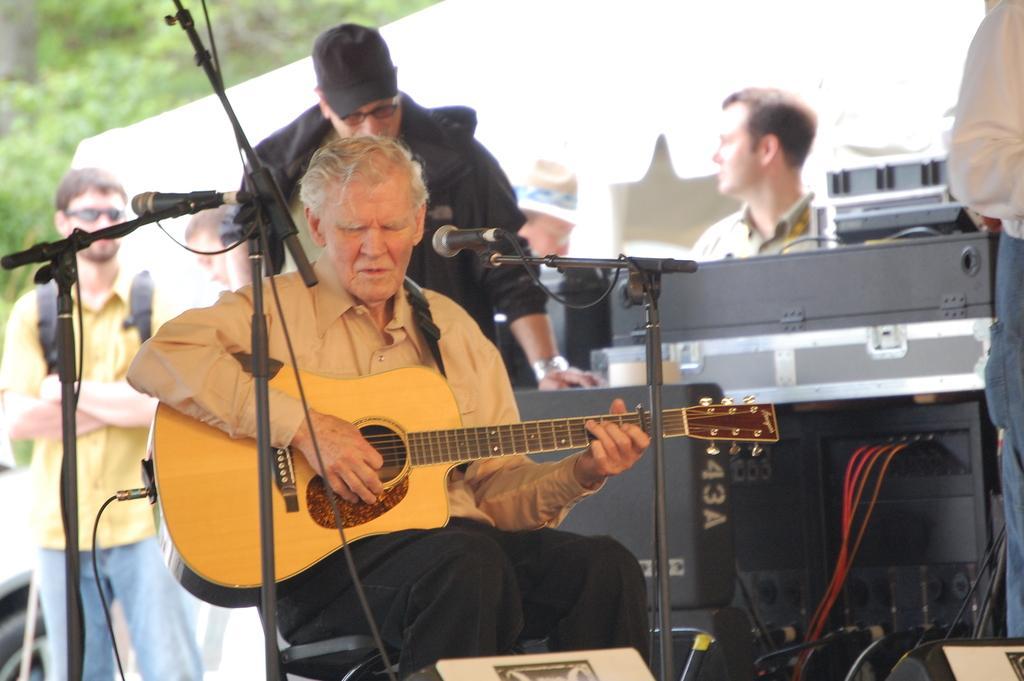How would you summarize this image in a sentence or two? In this picture there is a guy who is sitting on the chair and playing some musical instrument and behind there are some other people who are playing some other musical instruments. 